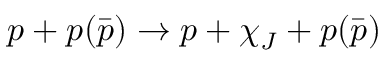<formula> <loc_0><loc_0><loc_500><loc_500>p + p ( \bar { p } ) \rightarrow p + \chi _ { J } + p ( \bar { p } )</formula> 